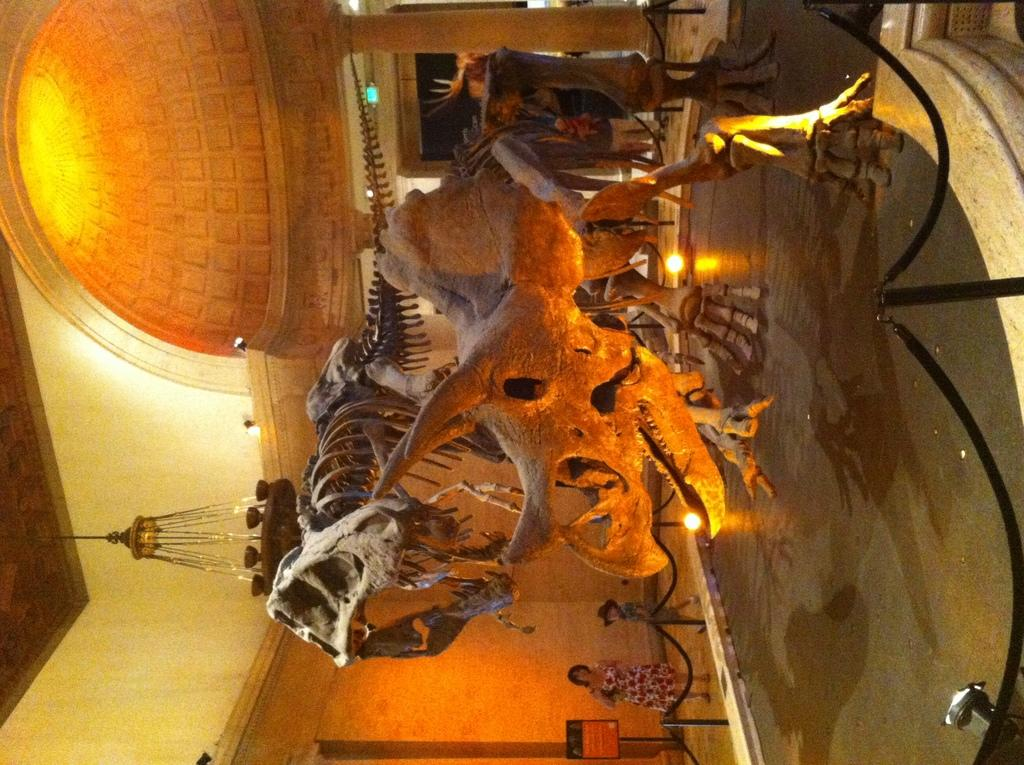What type of objects can be seen in the image? There are skeletons in the image. What else can be seen in the image besides the skeletons? There are lights and a board visible in the image. Who is present in the image? There is a woman standing in the image. What can be seen in the background of the image? There is a wall in the background of the image. What type of rod is the woman using to cause a vacation in the image? There is no rod or vacation mentioned in the image; it features skeletons, lights, a board, a woman, and a wall. 